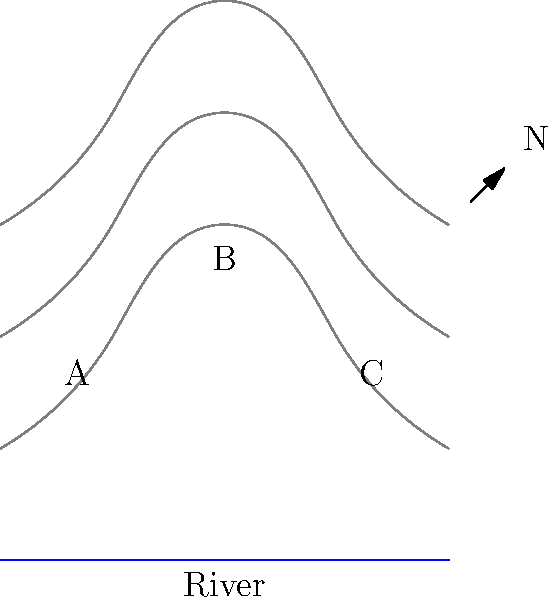Given the topographic map above, which point (A, B, or C) would be the best location for an ambush on prey approaching the river from the north? To determine the best ambush spot, we need to consider several factors:

1. Elevation: Higher ground provides a better vantage point.
2. Cover: Areas with more contour lines close together indicate steeper terrain, which can offer better concealment.
3. Prey movement: Animals often follow the path of least resistance when moving to water sources.

Analyzing each point:

A: Located on lower ground, with fewer contour lines nearby. It offers less cover and a limited view of approaching prey.

B: Situated at the highest point on the map, as indicated by the density of contour lines. It provides an excellent vantage point to spot prey from afar.

C: Similar elevation to point A, but with slightly more cover due to the closer contour lines.

Point B is the optimal choice because:
1. It has the highest elevation, allowing for a wide field of view.
2. The steep terrain (indicated by close contour lines) provides good cover for an ambush.
3. Prey moving towards the river from the north would likely pass near this point, following the path of least resistance along the ridge.

From point B, a wolf could spot prey early, plan its approach, and use the terrain's steepness for a swift and surprising attack.
Answer: B 